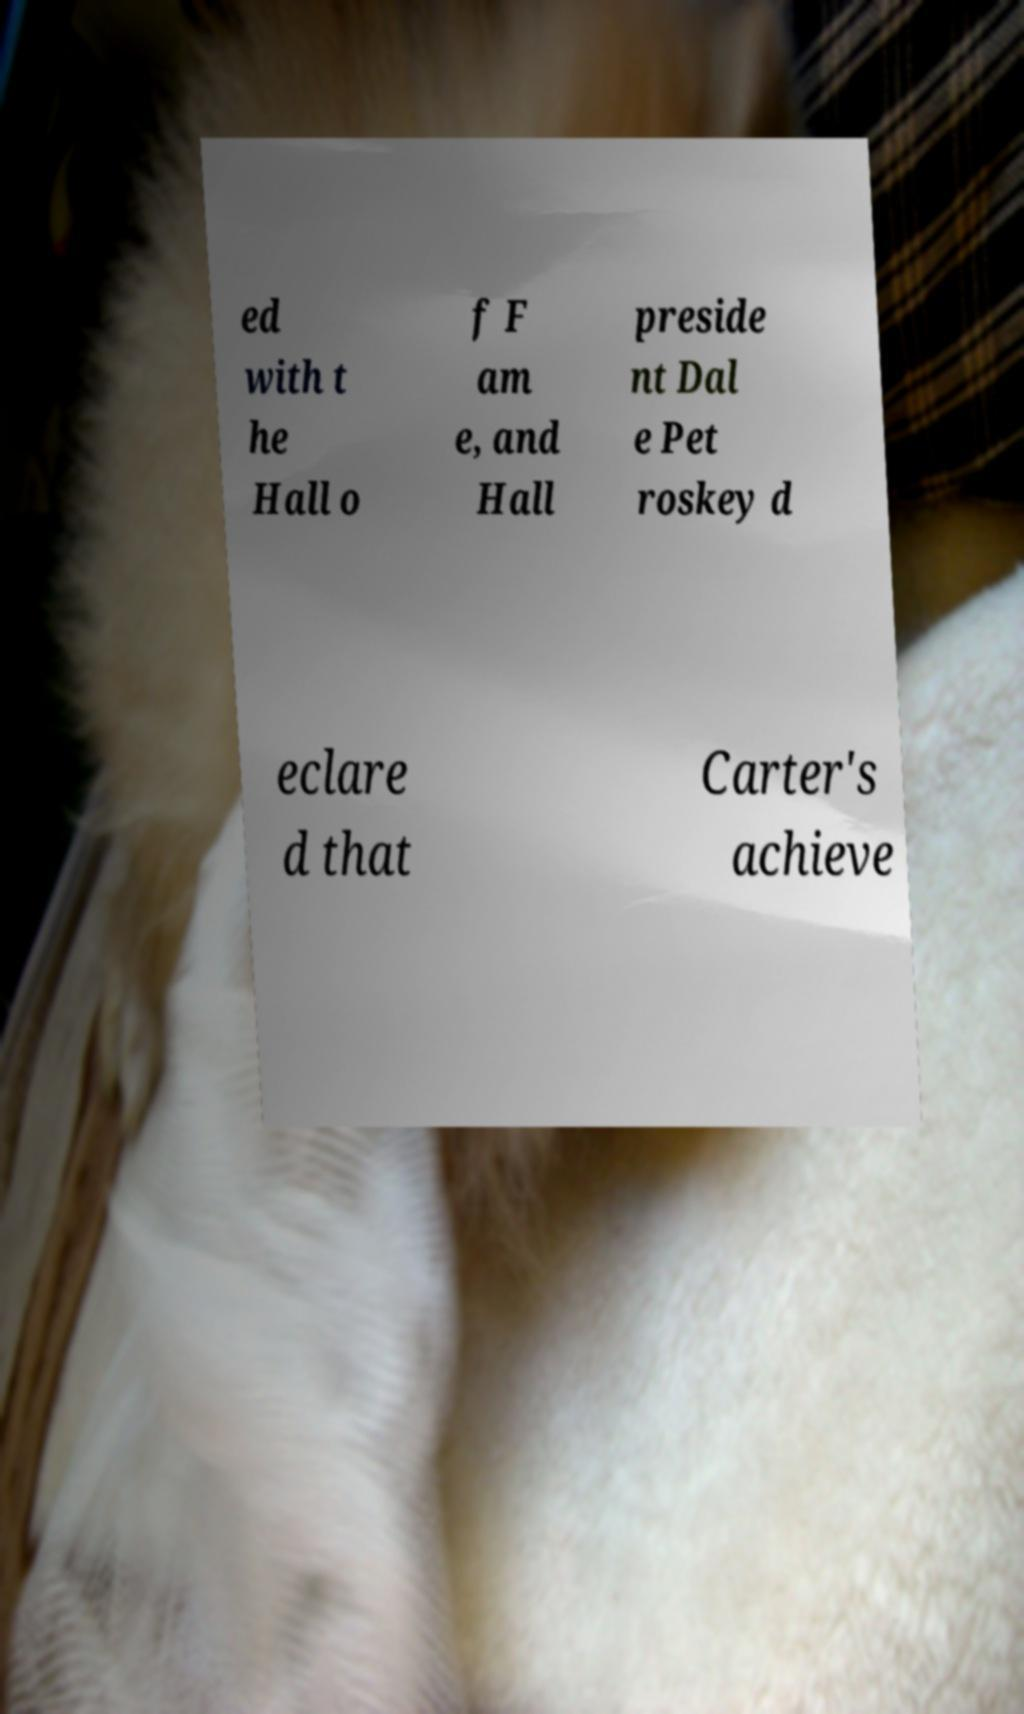I need the written content from this picture converted into text. Can you do that? ed with t he Hall o f F am e, and Hall preside nt Dal e Pet roskey d eclare d that Carter's achieve 